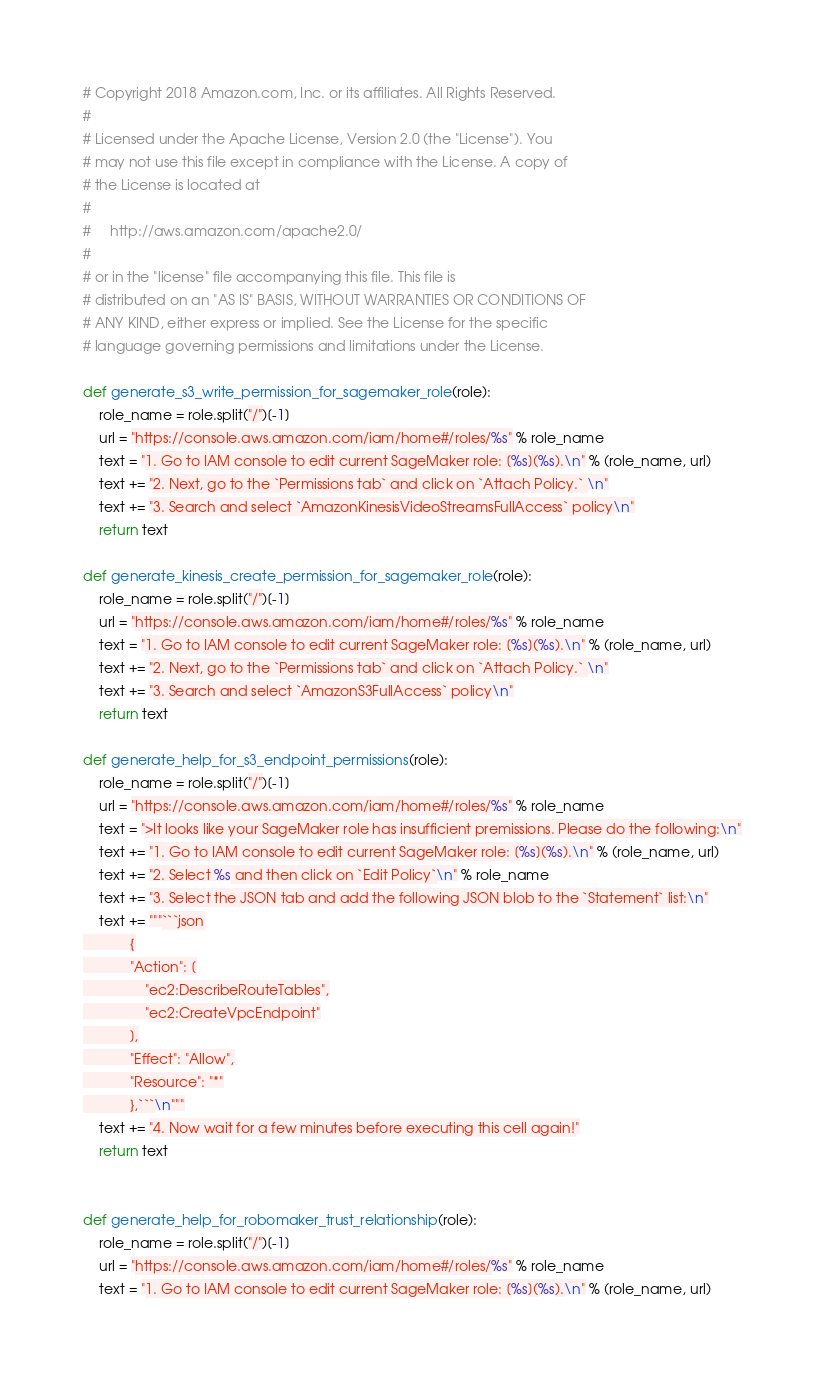Convert code to text. <code><loc_0><loc_0><loc_500><loc_500><_Python_># Copyright 2018 Amazon.com, Inc. or its affiliates. All Rights Reserved.
#
# Licensed under the Apache License, Version 2.0 (the "License"). You
# may not use this file except in compliance with the License. A copy of
# the License is located at
#
#     http://aws.amazon.com/apache2.0/
#
# or in the "license" file accompanying this file. This file is
# distributed on an "AS IS" BASIS, WITHOUT WARRANTIES OR CONDITIONS OF
# ANY KIND, either express or implied. See the License for the specific
# language governing permissions and limitations under the License.

def generate_s3_write_permission_for_sagemaker_role(role):
    role_name = role.split("/")[-1]
    url = "https://console.aws.amazon.com/iam/home#/roles/%s" % role_name
    text = "1. Go to IAM console to edit current SageMaker role: [%s](%s).\n" % (role_name, url)
    text += "2. Next, go to the `Permissions tab` and click on `Attach Policy.` \n"
    text += "3. Search and select `AmazonKinesisVideoStreamsFullAccess` policy\n"
    return text

def generate_kinesis_create_permission_for_sagemaker_role(role):
    role_name = role.split("/")[-1]
    url = "https://console.aws.amazon.com/iam/home#/roles/%s" % role_name
    text = "1. Go to IAM console to edit current SageMaker role: [%s](%s).\n" % (role_name, url)
    text += "2. Next, go to the `Permissions tab` and click on `Attach Policy.` \n"
    text += "3. Search and select `AmazonS3FullAccess` policy\n"
    return text

def generate_help_for_s3_endpoint_permissions(role):
    role_name = role.split("/")[-1]
    url = "https://console.aws.amazon.com/iam/home#/roles/%s" % role_name
    text = ">It looks like your SageMaker role has insufficient premissions. Please do the following:\n"
    text += "1. Go to IAM console to edit current SageMaker role: [%s](%s).\n" % (role_name, url)
    text += "2. Select %s and then click on `Edit Policy`\n" % role_name
    text += "3. Select the JSON tab and add the following JSON blob to the `Statement` list:\n"
    text += """```json
            {
            "Action": [
                "ec2:DescribeRouteTables",
                "ec2:CreateVpcEndpoint"
            ],
            "Effect": "Allow",
            "Resource": "*"
            },```\n"""
    text += "4. Now wait for a few minutes before executing this cell again!"
    return text


def generate_help_for_robomaker_trust_relationship(role):
    role_name = role.split("/")[-1]
    url = "https://console.aws.amazon.com/iam/home#/roles/%s" % role_name
    text = "1. Go to IAM console to edit current SageMaker role: [%s](%s).\n" % (role_name, url)</code> 